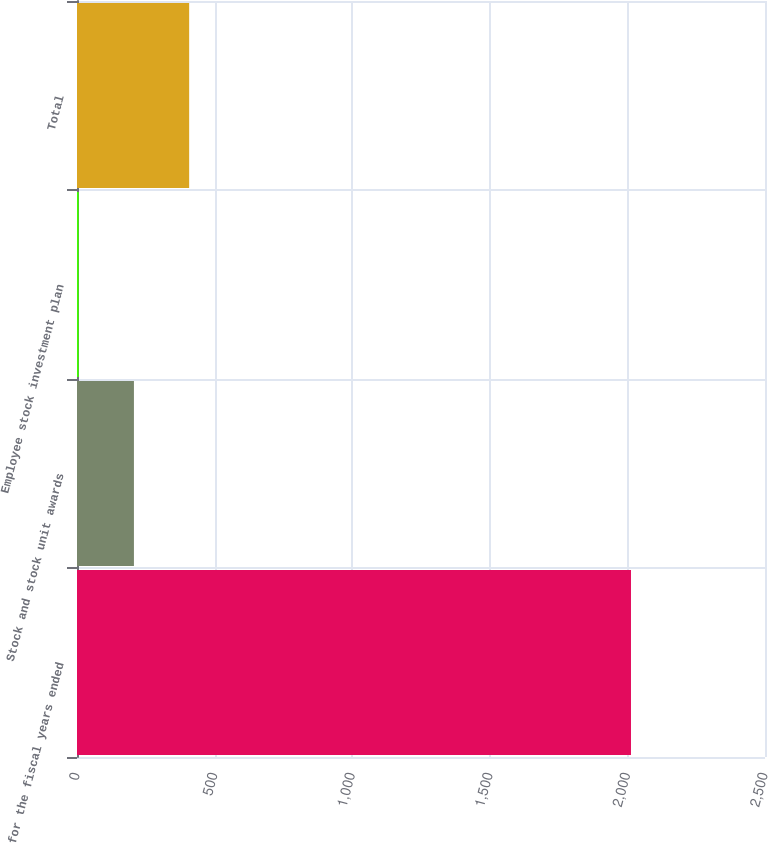<chart> <loc_0><loc_0><loc_500><loc_500><bar_chart><fcel>for the fiscal years ended<fcel>Stock and stock unit awards<fcel>Employee stock investment plan<fcel>Total<nl><fcel>2013<fcel>206.88<fcel>6.2<fcel>407.56<nl></chart> 